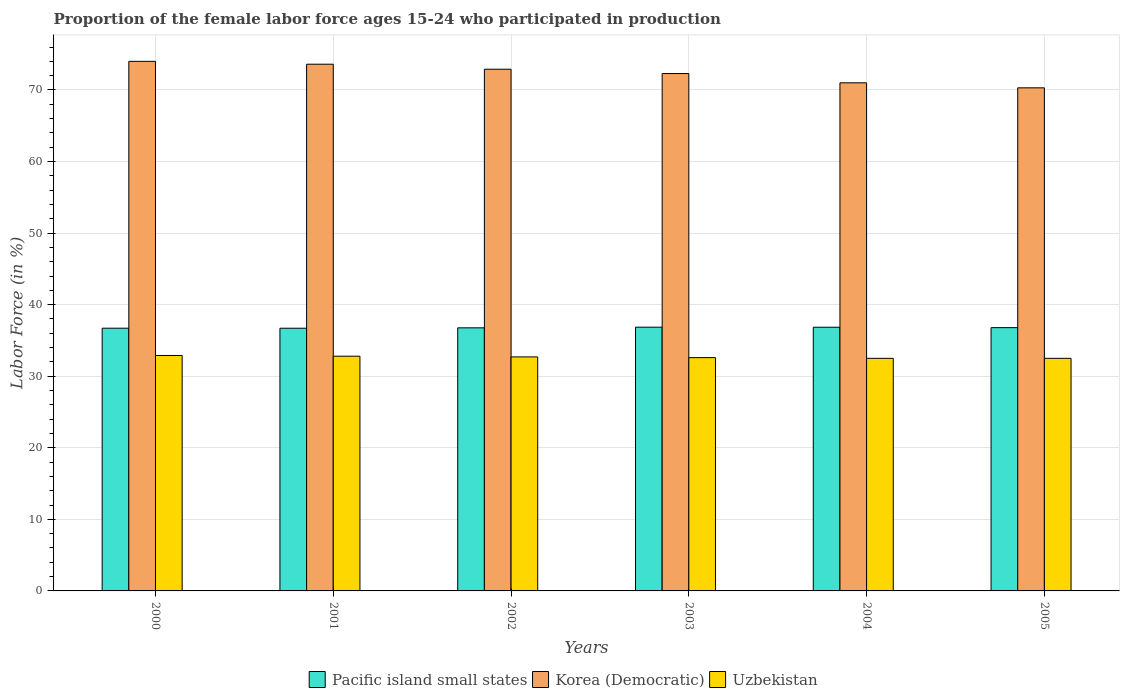Are the number of bars on each tick of the X-axis equal?
Ensure brevity in your answer.  Yes. What is the proportion of the female labor force who participated in production in Uzbekistan in 2005?
Make the answer very short. 32.5. Across all years, what is the maximum proportion of the female labor force who participated in production in Pacific island small states?
Provide a short and direct response. 36.85. Across all years, what is the minimum proportion of the female labor force who participated in production in Uzbekistan?
Offer a very short reply. 32.5. In which year was the proportion of the female labor force who participated in production in Korea (Democratic) minimum?
Ensure brevity in your answer.  2005. What is the total proportion of the female labor force who participated in production in Uzbekistan in the graph?
Keep it short and to the point. 196. What is the difference between the proportion of the female labor force who participated in production in Uzbekistan in 2003 and that in 2004?
Give a very brief answer. 0.1. What is the difference between the proportion of the female labor force who participated in production in Korea (Democratic) in 2000 and the proportion of the female labor force who participated in production in Pacific island small states in 2003?
Make the answer very short. 37.15. What is the average proportion of the female labor force who participated in production in Uzbekistan per year?
Provide a succinct answer. 32.67. In the year 2002, what is the difference between the proportion of the female labor force who participated in production in Korea (Democratic) and proportion of the female labor force who participated in production in Uzbekistan?
Offer a terse response. 40.2. What is the ratio of the proportion of the female labor force who participated in production in Pacific island small states in 2000 to that in 2003?
Give a very brief answer. 1. Is the difference between the proportion of the female labor force who participated in production in Korea (Democratic) in 2002 and 2004 greater than the difference between the proportion of the female labor force who participated in production in Uzbekistan in 2002 and 2004?
Keep it short and to the point. Yes. What is the difference between the highest and the second highest proportion of the female labor force who participated in production in Korea (Democratic)?
Keep it short and to the point. 0.4. What is the difference between the highest and the lowest proportion of the female labor force who participated in production in Korea (Democratic)?
Offer a very short reply. 3.7. In how many years, is the proportion of the female labor force who participated in production in Uzbekistan greater than the average proportion of the female labor force who participated in production in Uzbekistan taken over all years?
Your answer should be very brief. 3. What does the 1st bar from the left in 2001 represents?
Your answer should be very brief. Pacific island small states. What does the 2nd bar from the right in 2003 represents?
Offer a very short reply. Korea (Democratic). Is it the case that in every year, the sum of the proportion of the female labor force who participated in production in Pacific island small states and proportion of the female labor force who participated in production in Korea (Democratic) is greater than the proportion of the female labor force who participated in production in Uzbekistan?
Your response must be concise. Yes. What is the difference between two consecutive major ticks on the Y-axis?
Ensure brevity in your answer.  10. Are the values on the major ticks of Y-axis written in scientific E-notation?
Ensure brevity in your answer.  No. Does the graph contain any zero values?
Make the answer very short. No. Does the graph contain grids?
Offer a very short reply. Yes. What is the title of the graph?
Ensure brevity in your answer.  Proportion of the female labor force ages 15-24 who participated in production. Does "Indonesia" appear as one of the legend labels in the graph?
Offer a terse response. No. What is the label or title of the X-axis?
Provide a succinct answer. Years. What is the label or title of the Y-axis?
Offer a very short reply. Labor Force (in %). What is the Labor Force (in %) of Pacific island small states in 2000?
Provide a short and direct response. 36.71. What is the Labor Force (in %) of Korea (Democratic) in 2000?
Provide a short and direct response. 74. What is the Labor Force (in %) in Uzbekistan in 2000?
Your response must be concise. 32.9. What is the Labor Force (in %) of Pacific island small states in 2001?
Offer a terse response. 36.71. What is the Labor Force (in %) of Korea (Democratic) in 2001?
Keep it short and to the point. 73.6. What is the Labor Force (in %) in Uzbekistan in 2001?
Offer a very short reply. 32.8. What is the Labor Force (in %) of Pacific island small states in 2002?
Offer a very short reply. 36.76. What is the Labor Force (in %) of Korea (Democratic) in 2002?
Provide a short and direct response. 72.9. What is the Labor Force (in %) in Uzbekistan in 2002?
Provide a succinct answer. 32.7. What is the Labor Force (in %) in Pacific island small states in 2003?
Make the answer very short. 36.85. What is the Labor Force (in %) of Korea (Democratic) in 2003?
Keep it short and to the point. 72.3. What is the Labor Force (in %) of Uzbekistan in 2003?
Keep it short and to the point. 32.6. What is the Labor Force (in %) in Pacific island small states in 2004?
Keep it short and to the point. 36.85. What is the Labor Force (in %) of Uzbekistan in 2004?
Keep it short and to the point. 32.5. What is the Labor Force (in %) of Pacific island small states in 2005?
Your answer should be compact. 36.79. What is the Labor Force (in %) in Korea (Democratic) in 2005?
Offer a very short reply. 70.3. What is the Labor Force (in %) of Uzbekistan in 2005?
Offer a terse response. 32.5. Across all years, what is the maximum Labor Force (in %) in Pacific island small states?
Your answer should be very brief. 36.85. Across all years, what is the maximum Labor Force (in %) of Uzbekistan?
Provide a short and direct response. 32.9. Across all years, what is the minimum Labor Force (in %) in Pacific island small states?
Offer a very short reply. 36.71. Across all years, what is the minimum Labor Force (in %) in Korea (Democratic)?
Provide a succinct answer. 70.3. Across all years, what is the minimum Labor Force (in %) in Uzbekistan?
Provide a short and direct response. 32.5. What is the total Labor Force (in %) in Pacific island small states in the graph?
Provide a succinct answer. 220.67. What is the total Labor Force (in %) in Korea (Democratic) in the graph?
Offer a terse response. 434.1. What is the total Labor Force (in %) of Uzbekistan in the graph?
Your response must be concise. 196. What is the difference between the Labor Force (in %) in Pacific island small states in 2000 and that in 2001?
Keep it short and to the point. 0. What is the difference between the Labor Force (in %) of Pacific island small states in 2000 and that in 2002?
Offer a terse response. -0.05. What is the difference between the Labor Force (in %) in Korea (Democratic) in 2000 and that in 2002?
Give a very brief answer. 1.1. What is the difference between the Labor Force (in %) in Uzbekistan in 2000 and that in 2002?
Your answer should be very brief. 0.2. What is the difference between the Labor Force (in %) in Pacific island small states in 2000 and that in 2003?
Ensure brevity in your answer.  -0.14. What is the difference between the Labor Force (in %) in Korea (Democratic) in 2000 and that in 2003?
Provide a short and direct response. 1.7. What is the difference between the Labor Force (in %) of Pacific island small states in 2000 and that in 2004?
Provide a succinct answer. -0.14. What is the difference between the Labor Force (in %) of Uzbekistan in 2000 and that in 2004?
Keep it short and to the point. 0.4. What is the difference between the Labor Force (in %) in Pacific island small states in 2000 and that in 2005?
Keep it short and to the point. -0.08. What is the difference between the Labor Force (in %) in Korea (Democratic) in 2000 and that in 2005?
Offer a very short reply. 3.7. What is the difference between the Labor Force (in %) of Uzbekistan in 2000 and that in 2005?
Offer a terse response. 0.4. What is the difference between the Labor Force (in %) of Pacific island small states in 2001 and that in 2002?
Offer a very short reply. -0.05. What is the difference between the Labor Force (in %) in Pacific island small states in 2001 and that in 2003?
Your answer should be very brief. -0.15. What is the difference between the Labor Force (in %) in Korea (Democratic) in 2001 and that in 2003?
Your answer should be compact. 1.3. What is the difference between the Labor Force (in %) of Uzbekistan in 2001 and that in 2003?
Offer a very short reply. 0.2. What is the difference between the Labor Force (in %) in Pacific island small states in 2001 and that in 2004?
Make the answer very short. -0.14. What is the difference between the Labor Force (in %) of Uzbekistan in 2001 and that in 2004?
Make the answer very short. 0.3. What is the difference between the Labor Force (in %) in Pacific island small states in 2001 and that in 2005?
Offer a terse response. -0.08. What is the difference between the Labor Force (in %) in Korea (Democratic) in 2001 and that in 2005?
Your answer should be compact. 3.3. What is the difference between the Labor Force (in %) in Pacific island small states in 2002 and that in 2003?
Give a very brief answer. -0.09. What is the difference between the Labor Force (in %) of Uzbekistan in 2002 and that in 2003?
Give a very brief answer. 0.1. What is the difference between the Labor Force (in %) in Pacific island small states in 2002 and that in 2004?
Give a very brief answer. -0.08. What is the difference between the Labor Force (in %) in Uzbekistan in 2002 and that in 2004?
Provide a succinct answer. 0.2. What is the difference between the Labor Force (in %) of Pacific island small states in 2002 and that in 2005?
Your answer should be very brief. -0.03. What is the difference between the Labor Force (in %) of Korea (Democratic) in 2002 and that in 2005?
Your answer should be very brief. 2.6. What is the difference between the Labor Force (in %) of Pacific island small states in 2003 and that in 2004?
Your answer should be very brief. 0.01. What is the difference between the Labor Force (in %) of Pacific island small states in 2003 and that in 2005?
Ensure brevity in your answer.  0.07. What is the difference between the Labor Force (in %) of Korea (Democratic) in 2003 and that in 2005?
Provide a short and direct response. 2. What is the difference between the Labor Force (in %) of Uzbekistan in 2003 and that in 2005?
Give a very brief answer. 0.1. What is the difference between the Labor Force (in %) in Pacific island small states in 2004 and that in 2005?
Give a very brief answer. 0.06. What is the difference between the Labor Force (in %) in Pacific island small states in 2000 and the Labor Force (in %) in Korea (Democratic) in 2001?
Provide a short and direct response. -36.89. What is the difference between the Labor Force (in %) in Pacific island small states in 2000 and the Labor Force (in %) in Uzbekistan in 2001?
Provide a short and direct response. 3.91. What is the difference between the Labor Force (in %) of Korea (Democratic) in 2000 and the Labor Force (in %) of Uzbekistan in 2001?
Offer a very short reply. 41.2. What is the difference between the Labor Force (in %) of Pacific island small states in 2000 and the Labor Force (in %) of Korea (Democratic) in 2002?
Keep it short and to the point. -36.19. What is the difference between the Labor Force (in %) in Pacific island small states in 2000 and the Labor Force (in %) in Uzbekistan in 2002?
Ensure brevity in your answer.  4.01. What is the difference between the Labor Force (in %) of Korea (Democratic) in 2000 and the Labor Force (in %) of Uzbekistan in 2002?
Keep it short and to the point. 41.3. What is the difference between the Labor Force (in %) in Pacific island small states in 2000 and the Labor Force (in %) in Korea (Democratic) in 2003?
Ensure brevity in your answer.  -35.59. What is the difference between the Labor Force (in %) of Pacific island small states in 2000 and the Labor Force (in %) of Uzbekistan in 2003?
Your answer should be compact. 4.11. What is the difference between the Labor Force (in %) of Korea (Democratic) in 2000 and the Labor Force (in %) of Uzbekistan in 2003?
Your response must be concise. 41.4. What is the difference between the Labor Force (in %) in Pacific island small states in 2000 and the Labor Force (in %) in Korea (Democratic) in 2004?
Your response must be concise. -34.29. What is the difference between the Labor Force (in %) in Pacific island small states in 2000 and the Labor Force (in %) in Uzbekistan in 2004?
Offer a very short reply. 4.21. What is the difference between the Labor Force (in %) in Korea (Democratic) in 2000 and the Labor Force (in %) in Uzbekistan in 2004?
Offer a very short reply. 41.5. What is the difference between the Labor Force (in %) of Pacific island small states in 2000 and the Labor Force (in %) of Korea (Democratic) in 2005?
Your answer should be very brief. -33.59. What is the difference between the Labor Force (in %) of Pacific island small states in 2000 and the Labor Force (in %) of Uzbekistan in 2005?
Your answer should be compact. 4.21. What is the difference between the Labor Force (in %) in Korea (Democratic) in 2000 and the Labor Force (in %) in Uzbekistan in 2005?
Your response must be concise. 41.5. What is the difference between the Labor Force (in %) of Pacific island small states in 2001 and the Labor Force (in %) of Korea (Democratic) in 2002?
Your answer should be very brief. -36.19. What is the difference between the Labor Force (in %) of Pacific island small states in 2001 and the Labor Force (in %) of Uzbekistan in 2002?
Your response must be concise. 4.01. What is the difference between the Labor Force (in %) of Korea (Democratic) in 2001 and the Labor Force (in %) of Uzbekistan in 2002?
Keep it short and to the point. 40.9. What is the difference between the Labor Force (in %) in Pacific island small states in 2001 and the Labor Force (in %) in Korea (Democratic) in 2003?
Offer a terse response. -35.59. What is the difference between the Labor Force (in %) of Pacific island small states in 2001 and the Labor Force (in %) of Uzbekistan in 2003?
Offer a very short reply. 4.11. What is the difference between the Labor Force (in %) of Korea (Democratic) in 2001 and the Labor Force (in %) of Uzbekistan in 2003?
Offer a very short reply. 41. What is the difference between the Labor Force (in %) of Pacific island small states in 2001 and the Labor Force (in %) of Korea (Democratic) in 2004?
Ensure brevity in your answer.  -34.29. What is the difference between the Labor Force (in %) in Pacific island small states in 2001 and the Labor Force (in %) in Uzbekistan in 2004?
Your response must be concise. 4.21. What is the difference between the Labor Force (in %) in Korea (Democratic) in 2001 and the Labor Force (in %) in Uzbekistan in 2004?
Make the answer very short. 41.1. What is the difference between the Labor Force (in %) of Pacific island small states in 2001 and the Labor Force (in %) of Korea (Democratic) in 2005?
Provide a succinct answer. -33.59. What is the difference between the Labor Force (in %) of Pacific island small states in 2001 and the Labor Force (in %) of Uzbekistan in 2005?
Offer a terse response. 4.21. What is the difference between the Labor Force (in %) in Korea (Democratic) in 2001 and the Labor Force (in %) in Uzbekistan in 2005?
Provide a succinct answer. 41.1. What is the difference between the Labor Force (in %) of Pacific island small states in 2002 and the Labor Force (in %) of Korea (Democratic) in 2003?
Provide a succinct answer. -35.54. What is the difference between the Labor Force (in %) of Pacific island small states in 2002 and the Labor Force (in %) of Uzbekistan in 2003?
Keep it short and to the point. 4.16. What is the difference between the Labor Force (in %) of Korea (Democratic) in 2002 and the Labor Force (in %) of Uzbekistan in 2003?
Provide a short and direct response. 40.3. What is the difference between the Labor Force (in %) of Pacific island small states in 2002 and the Labor Force (in %) of Korea (Democratic) in 2004?
Offer a very short reply. -34.24. What is the difference between the Labor Force (in %) of Pacific island small states in 2002 and the Labor Force (in %) of Uzbekistan in 2004?
Give a very brief answer. 4.26. What is the difference between the Labor Force (in %) in Korea (Democratic) in 2002 and the Labor Force (in %) in Uzbekistan in 2004?
Give a very brief answer. 40.4. What is the difference between the Labor Force (in %) of Pacific island small states in 2002 and the Labor Force (in %) of Korea (Democratic) in 2005?
Your response must be concise. -33.54. What is the difference between the Labor Force (in %) in Pacific island small states in 2002 and the Labor Force (in %) in Uzbekistan in 2005?
Your response must be concise. 4.26. What is the difference between the Labor Force (in %) of Korea (Democratic) in 2002 and the Labor Force (in %) of Uzbekistan in 2005?
Your answer should be compact. 40.4. What is the difference between the Labor Force (in %) of Pacific island small states in 2003 and the Labor Force (in %) of Korea (Democratic) in 2004?
Your answer should be very brief. -34.15. What is the difference between the Labor Force (in %) in Pacific island small states in 2003 and the Labor Force (in %) in Uzbekistan in 2004?
Provide a short and direct response. 4.35. What is the difference between the Labor Force (in %) in Korea (Democratic) in 2003 and the Labor Force (in %) in Uzbekistan in 2004?
Give a very brief answer. 39.8. What is the difference between the Labor Force (in %) of Pacific island small states in 2003 and the Labor Force (in %) of Korea (Democratic) in 2005?
Your answer should be very brief. -33.45. What is the difference between the Labor Force (in %) in Pacific island small states in 2003 and the Labor Force (in %) in Uzbekistan in 2005?
Your answer should be very brief. 4.35. What is the difference between the Labor Force (in %) in Korea (Democratic) in 2003 and the Labor Force (in %) in Uzbekistan in 2005?
Offer a very short reply. 39.8. What is the difference between the Labor Force (in %) in Pacific island small states in 2004 and the Labor Force (in %) in Korea (Democratic) in 2005?
Keep it short and to the point. -33.45. What is the difference between the Labor Force (in %) of Pacific island small states in 2004 and the Labor Force (in %) of Uzbekistan in 2005?
Give a very brief answer. 4.35. What is the difference between the Labor Force (in %) of Korea (Democratic) in 2004 and the Labor Force (in %) of Uzbekistan in 2005?
Your response must be concise. 38.5. What is the average Labor Force (in %) of Pacific island small states per year?
Keep it short and to the point. 36.78. What is the average Labor Force (in %) in Korea (Democratic) per year?
Provide a short and direct response. 72.35. What is the average Labor Force (in %) in Uzbekistan per year?
Your response must be concise. 32.67. In the year 2000, what is the difference between the Labor Force (in %) in Pacific island small states and Labor Force (in %) in Korea (Democratic)?
Offer a very short reply. -37.29. In the year 2000, what is the difference between the Labor Force (in %) of Pacific island small states and Labor Force (in %) of Uzbekistan?
Make the answer very short. 3.81. In the year 2000, what is the difference between the Labor Force (in %) of Korea (Democratic) and Labor Force (in %) of Uzbekistan?
Keep it short and to the point. 41.1. In the year 2001, what is the difference between the Labor Force (in %) of Pacific island small states and Labor Force (in %) of Korea (Democratic)?
Provide a short and direct response. -36.89. In the year 2001, what is the difference between the Labor Force (in %) in Pacific island small states and Labor Force (in %) in Uzbekistan?
Ensure brevity in your answer.  3.91. In the year 2001, what is the difference between the Labor Force (in %) of Korea (Democratic) and Labor Force (in %) of Uzbekistan?
Offer a terse response. 40.8. In the year 2002, what is the difference between the Labor Force (in %) of Pacific island small states and Labor Force (in %) of Korea (Democratic)?
Ensure brevity in your answer.  -36.14. In the year 2002, what is the difference between the Labor Force (in %) in Pacific island small states and Labor Force (in %) in Uzbekistan?
Ensure brevity in your answer.  4.06. In the year 2002, what is the difference between the Labor Force (in %) of Korea (Democratic) and Labor Force (in %) of Uzbekistan?
Provide a succinct answer. 40.2. In the year 2003, what is the difference between the Labor Force (in %) of Pacific island small states and Labor Force (in %) of Korea (Democratic)?
Offer a very short reply. -35.45. In the year 2003, what is the difference between the Labor Force (in %) in Pacific island small states and Labor Force (in %) in Uzbekistan?
Offer a very short reply. 4.25. In the year 2003, what is the difference between the Labor Force (in %) in Korea (Democratic) and Labor Force (in %) in Uzbekistan?
Ensure brevity in your answer.  39.7. In the year 2004, what is the difference between the Labor Force (in %) in Pacific island small states and Labor Force (in %) in Korea (Democratic)?
Your response must be concise. -34.15. In the year 2004, what is the difference between the Labor Force (in %) in Pacific island small states and Labor Force (in %) in Uzbekistan?
Your answer should be compact. 4.35. In the year 2004, what is the difference between the Labor Force (in %) of Korea (Democratic) and Labor Force (in %) of Uzbekistan?
Offer a terse response. 38.5. In the year 2005, what is the difference between the Labor Force (in %) in Pacific island small states and Labor Force (in %) in Korea (Democratic)?
Your response must be concise. -33.51. In the year 2005, what is the difference between the Labor Force (in %) of Pacific island small states and Labor Force (in %) of Uzbekistan?
Your response must be concise. 4.29. In the year 2005, what is the difference between the Labor Force (in %) of Korea (Democratic) and Labor Force (in %) of Uzbekistan?
Offer a terse response. 37.8. What is the ratio of the Labor Force (in %) of Pacific island small states in 2000 to that in 2001?
Offer a terse response. 1. What is the ratio of the Labor Force (in %) of Korea (Democratic) in 2000 to that in 2001?
Give a very brief answer. 1.01. What is the ratio of the Labor Force (in %) in Korea (Democratic) in 2000 to that in 2002?
Ensure brevity in your answer.  1.02. What is the ratio of the Labor Force (in %) in Uzbekistan in 2000 to that in 2002?
Your answer should be very brief. 1.01. What is the ratio of the Labor Force (in %) of Pacific island small states in 2000 to that in 2003?
Make the answer very short. 1. What is the ratio of the Labor Force (in %) of Korea (Democratic) in 2000 to that in 2003?
Ensure brevity in your answer.  1.02. What is the ratio of the Labor Force (in %) in Uzbekistan in 2000 to that in 2003?
Your answer should be compact. 1.01. What is the ratio of the Labor Force (in %) in Korea (Democratic) in 2000 to that in 2004?
Your answer should be compact. 1.04. What is the ratio of the Labor Force (in %) of Uzbekistan in 2000 to that in 2004?
Make the answer very short. 1.01. What is the ratio of the Labor Force (in %) of Korea (Democratic) in 2000 to that in 2005?
Your answer should be compact. 1.05. What is the ratio of the Labor Force (in %) of Uzbekistan in 2000 to that in 2005?
Your answer should be compact. 1.01. What is the ratio of the Labor Force (in %) of Pacific island small states in 2001 to that in 2002?
Offer a very short reply. 1. What is the ratio of the Labor Force (in %) in Korea (Democratic) in 2001 to that in 2002?
Offer a terse response. 1.01. What is the ratio of the Labor Force (in %) of Uzbekistan in 2001 to that in 2002?
Make the answer very short. 1. What is the ratio of the Labor Force (in %) in Korea (Democratic) in 2001 to that in 2003?
Offer a terse response. 1.02. What is the ratio of the Labor Force (in %) of Uzbekistan in 2001 to that in 2003?
Give a very brief answer. 1.01. What is the ratio of the Labor Force (in %) in Korea (Democratic) in 2001 to that in 2004?
Ensure brevity in your answer.  1.04. What is the ratio of the Labor Force (in %) of Uzbekistan in 2001 to that in 2004?
Your response must be concise. 1.01. What is the ratio of the Labor Force (in %) in Korea (Democratic) in 2001 to that in 2005?
Provide a short and direct response. 1.05. What is the ratio of the Labor Force (in %) in Uzbekistan in 2001 to that in 2005?
Keep it short and to the point. 1.01. What is the ratio of the Labor Force (in %) of Pacific island small states in 2002 to that in 2003?
Your answer should be very brief. 1. What is the ratio of the Labor Force (in %) in Korea (Democratic) in 2002 to that in 2003?
Keep it short and to the point. 1.01. What is the ratio of the Labor Force (in %) of Uzbekistan in 2002 to that in 2003?
Offer a very short reply. 1. What is the ratio of the Labor Force (in %) of Pacific island small states in 2002 to that in 2004?
Offer a terse response. 1. What is the ratio of the Labor Force (in %) in Korea (Democratic) in 2002 to that in 2004?
Keep it short and to the point. 1.03. What is the ratio of the Labor Force (in %) in Uzbekistan in 2002 to that in 2005?
Your response must be concise. 1.01. What is the ratio of the Labor Force (in %) of Korea (Democratic) in 2003 to that in 2004?
Keep it short and to the point. 1.02. What is the ratio of the Labor Force (in %) in Uzbekistan in 2003 to that in 2004?
Make the answer very short. 1. What is the ratio of the Labor Force (in %) of Korea (Democratic) in 2003 to that in 2005?
Your response must be concise. 1.03. What is the ratio of the Labor Force (in %) of Pacific island small states in 2004 to that in 2005?
Provide a succinct answer. 1. What is the ratio of the Labor Force (in %) in Korea (Democratic) in 2004 to that in 2005?
Your answer should be very brief. 1.01. What is the ratio of the Labor Force (in %) in Uzbekistan in 2004 to that in 2005?
Ensure brevity in your answer.  1. What is the difference between the highest and the second highest Labor Force (in %) of Pacific island small states?
Provide a succinct answer. 0.01. What is the difference between the highest and the lowest Labor Force (in %) in Pacific island small states?
Your answer should be very brief. 0.15. 